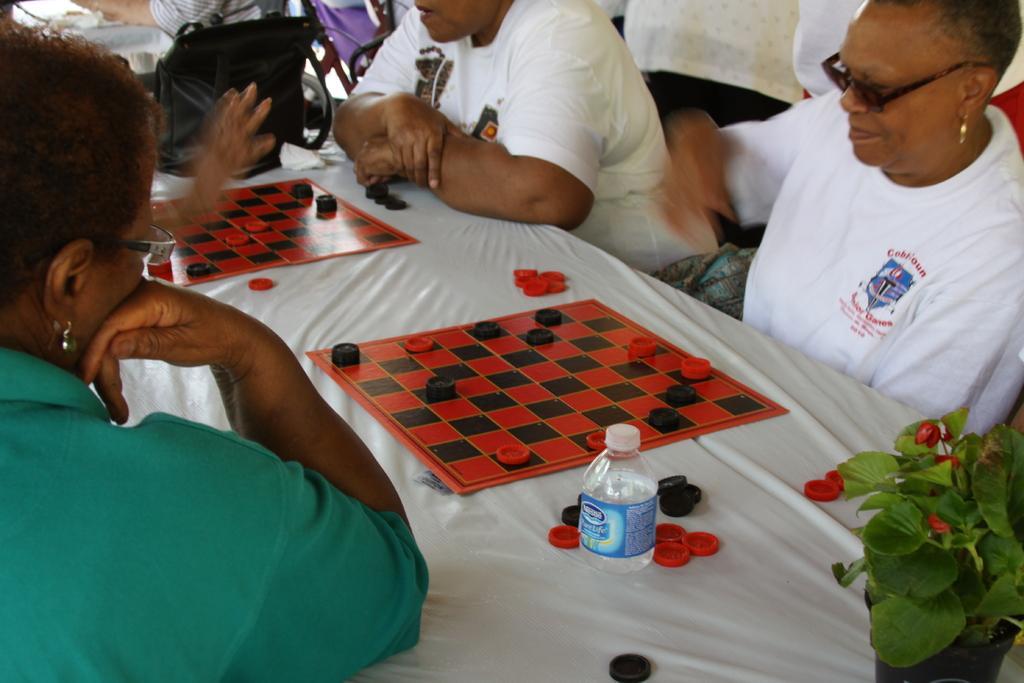In one or two sentences, can you explain what this image depicts? As we can see in the image there is a table and few people sitting. On table there is bottle, plant, coins and chess boards. 